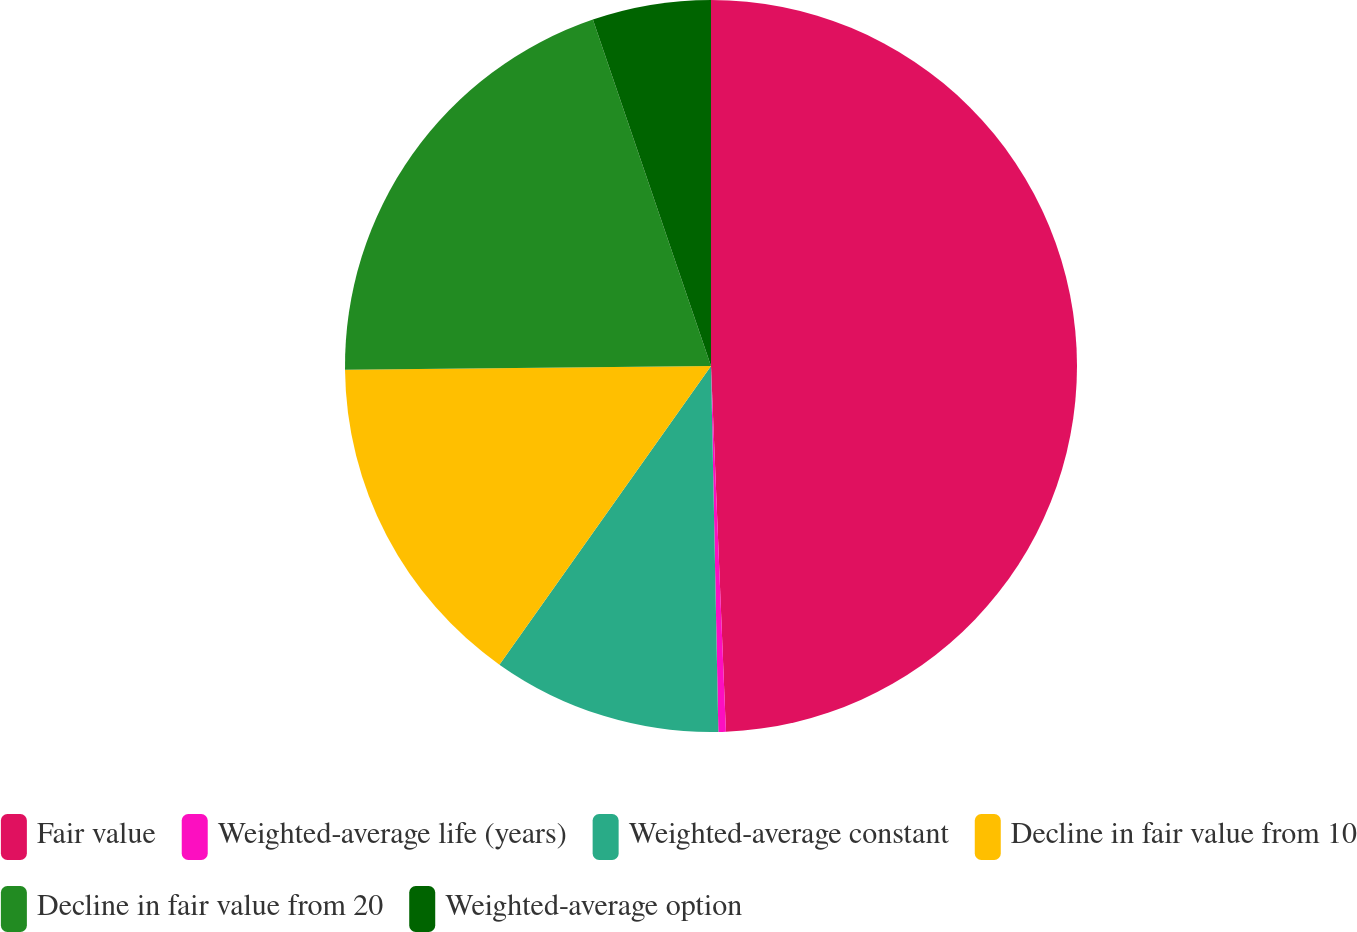<chart> <loc_0><loc_0><loc_500><loc_500><pie_chart><fcel>Fair value<fcel>Weighted-average life (years)<fcel>Weighted-average constant<fcel>Decline in fair value from 10<fcel>Decline in fair value from 20<fcel>Weighted-average option<nl><fcel>49.35%<fcel>0.33%<fcel>10.13%<fcel>15.03%<fcel>19.93%<fcel>5.23%<nl></chart> 